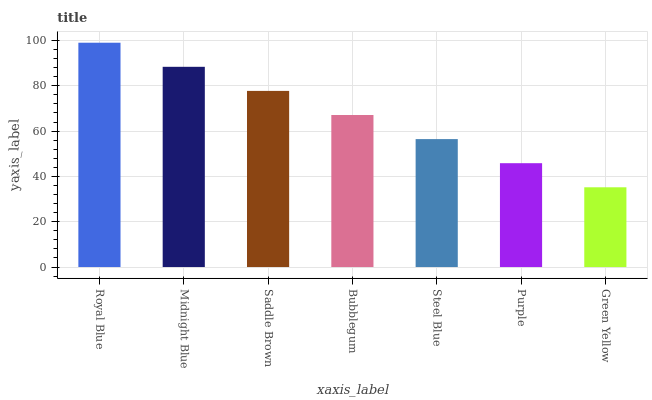Is Midnight Blue the minimum?
Answer yes or no. No. Is Midnight Blue the maximum?
Answer yes or no. No. Is Royal Blue greater than Midnight Blue?
Answer yes or no. Yes. Is Midnight Blue less than Royal Blue?
Answer yes or no. Yes. Is Midnight Blue greater than Royal Blue?
Answer yes or no. No. Is Royal Blue less than Midnight Blue?
Answer yes or no. No. Is Bubblegum the high median?
Answer yes or no. Yes. Is Bubblegum the low median?
Answer yes or no. Yes. Is Royal Blue the high median?
Answer yes or no. No. Is Royal Blue the low median?
Answer yes or no. No. 